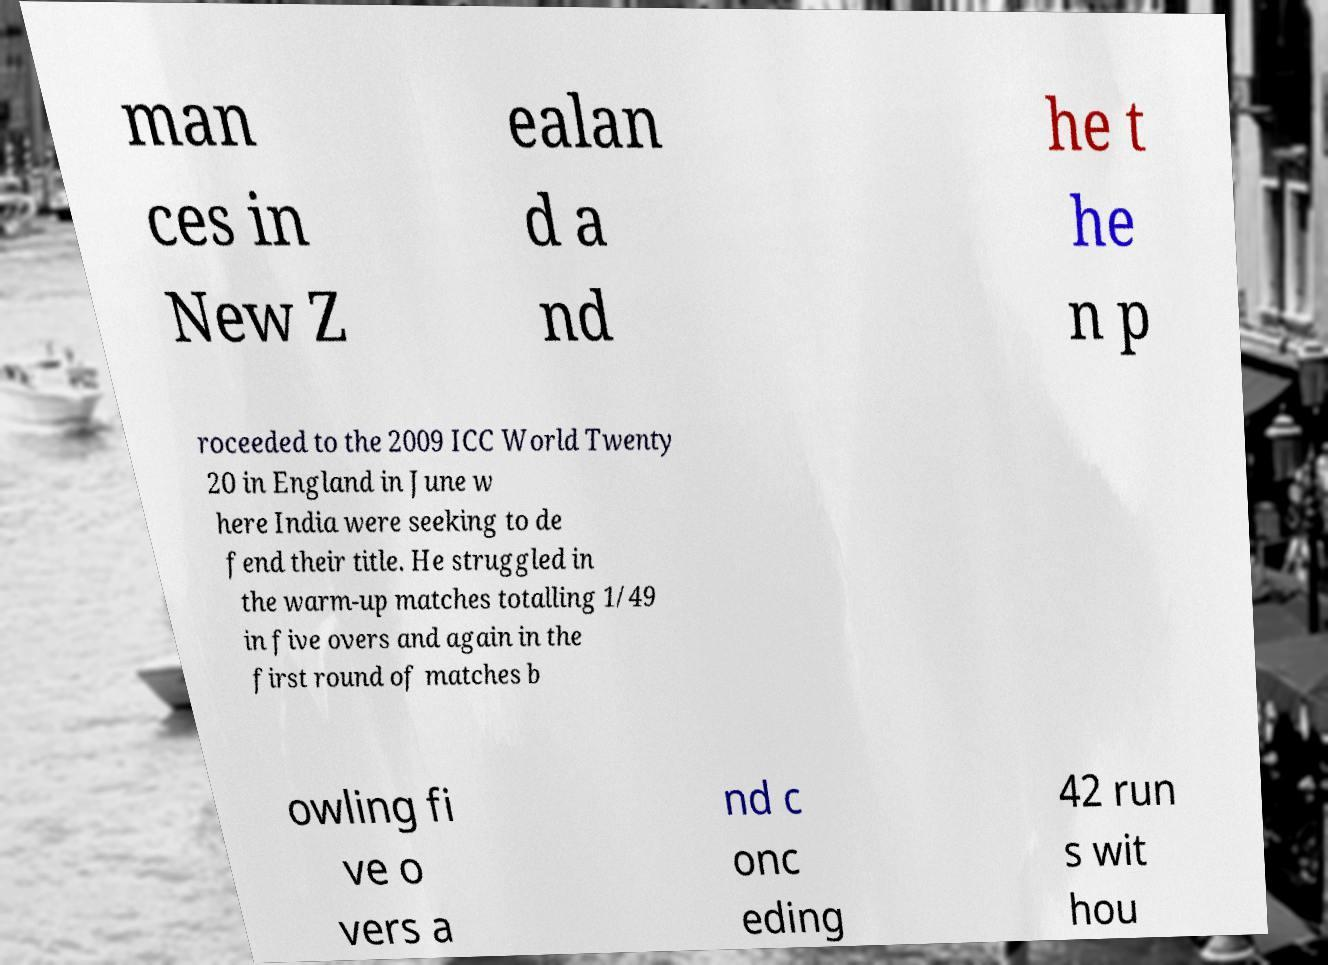Can you accurately transcribe the text from the provided image for me? man ces in New Z ealan d a nd he t he n p roceeded to the 2009 ICC World Twenty 20 in England in June w here India were seeking to de fend their title. He struggled in the warm-up matches totalling 1/49 in five overs and again in the first round of matches b owling fi ve o vers a nd c onc eding 42 run s wit hou 